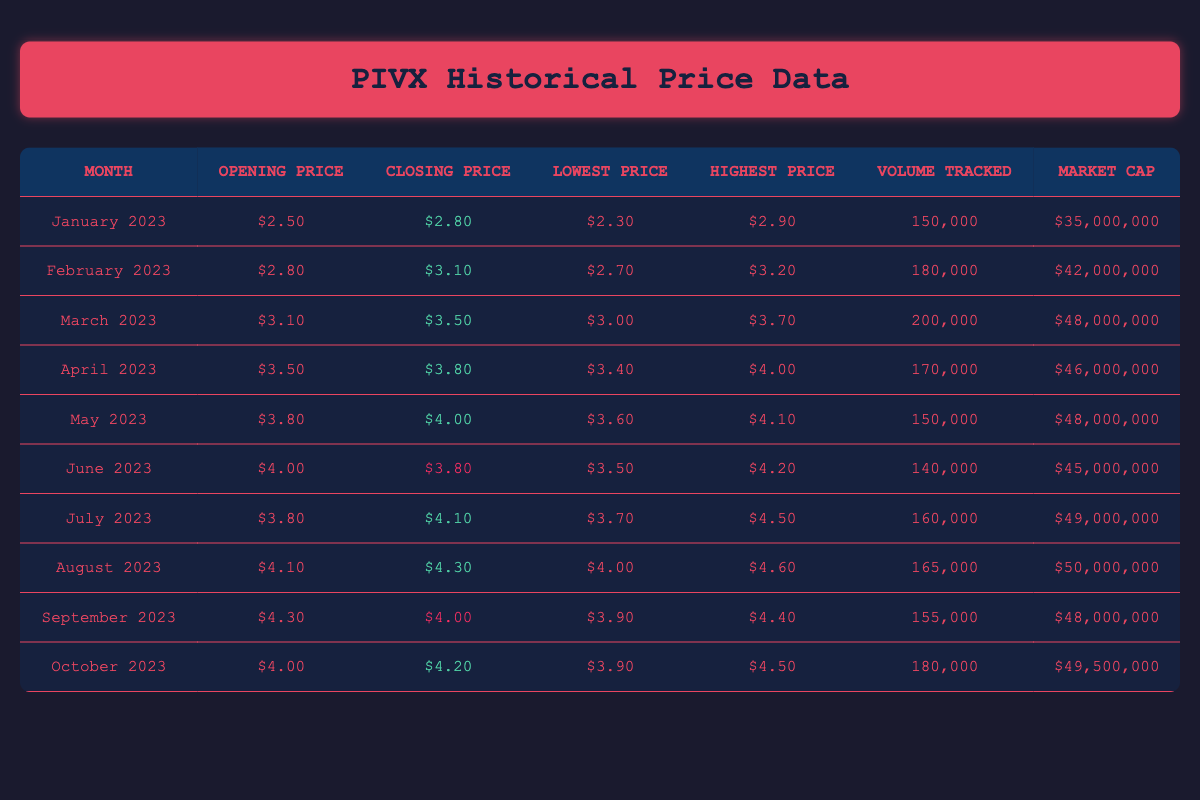What was the highest price of PIVX recorded in April 2023? In April 2023, the highest price listed is $4.00. This value is found in the "Highest Price" column for that month.
Answer: $4.00 What was the market cap in June 2023? In June 2023, the market cap shown is $45,000,000. This value is directly found in the "Market Cap" column for that month.
Answer: $45,000,000 Which month had the highest volume tracked? March 2023 had the highest volume tracked at 200,000. This can be seen by comparing the "Volume Tracked" values for each month.
Answer: March 2023 What is the average closing price for the months of June, July, and August 2023? The closing prices for those months are June: $3.80, July: $4.10, and August: $4.30. Adding them gives $3.80 + $4.10 + $4.30 = $12.20. Dividing by 3 (the number of months) gives an average of $12.20 / 3 = $4.07.
Answer: $4.07 Did PIVX close higher in March or April 2023? In March 2023, the closing price was $3.50, while in April 2023, it was $3.80. Since $3.80 is greater than $3.50, PIVX closed higher in April.
Answer: Yes, higher in April Was the closing price in September lower than that in July? The closing price in September 2023 is $4.00, and in July 2023, it was $4.10. Since $4.00 is less than $4.10, the closing price is indeed lower in September.
Answer: Yes, lower in September Which month saw the largest increase in closing price compared to the previous month? Observing the closing prices: January ($2.80), February ($3.10) shows an increase of $0.30; February to March ($3.50) is an increase of $0.40; March to April ($3.80) is an increase of $0.30; April to May ($4.00) is an increase of $0.20; May to June ($3.80) is a decrease; etc. The largest increase is from February to March with $0.40 increase.
Answer: February to March What was the difference between the lowest and highest prices in October 2023? The lowest price in October 2023 was $3.90, and the highest price was $4.50. The difference is $4.50 - $3.90 = $0.60.
Answer: $0.60 Was the market cap higher in February or March 2023? The market cap for February 2023 was $42,000,000, while for March 2023 it was $48,000,000. Since $48,000,000 is greater than $42,000,000, the market cap in March was higher.
Answer: Yes, higher in March What was the net change in closing price from January to October 2023? January closed at $2.80, while October closed at $4.20. The net change is $4.20 - $2.80 = $1.40.
Answer: $1.40 increase 